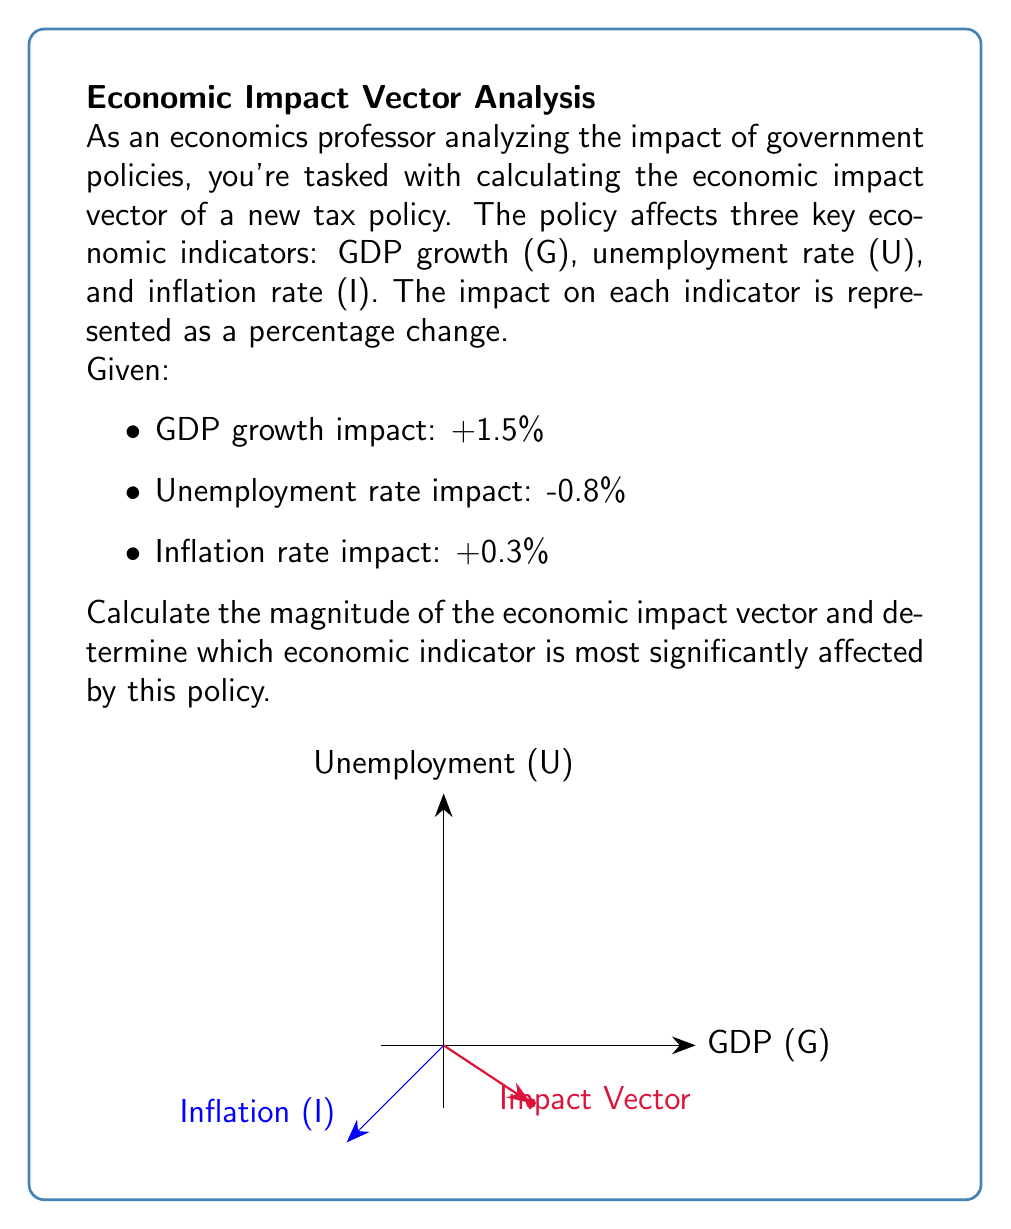Help me with this question. To solve this problem, we'll follow these steps:

1) First, we need to represent the economic impact as a 3D vector:
   $\vec{v} = (1.5, -0.8, 0.3)$

2) To calculate the magnitude of this vector, we use the formula:
   $|\vec{v}| = \sqrt{x^2 + y^2 + z^2}$

3) Substituting our values:
   $|\vec{v}| = \sqrt{1.5^2 + (-0.8)^2 + 0.3^2}$

4) Simplify:
   $|\vec{v}| = \sqrt{2.25 + 0.64 + 0.09}$
   $|\vec{v}| = \sqrt{2.98}$
   $|\vec{v}| \approx 1.73$

5) To determine which indicator is most significantly affected, we compare the absolute values of the components:
   |GDP growth impact| = 1.5
   |Unemployment rate impact| = 0.8
   |Inflation rate impact| = 0.3

6) The largest absolute value is 1.5, corresponding to GDP growth.
Answer: Magnitude: 1.73; Most affected: GDP growth 